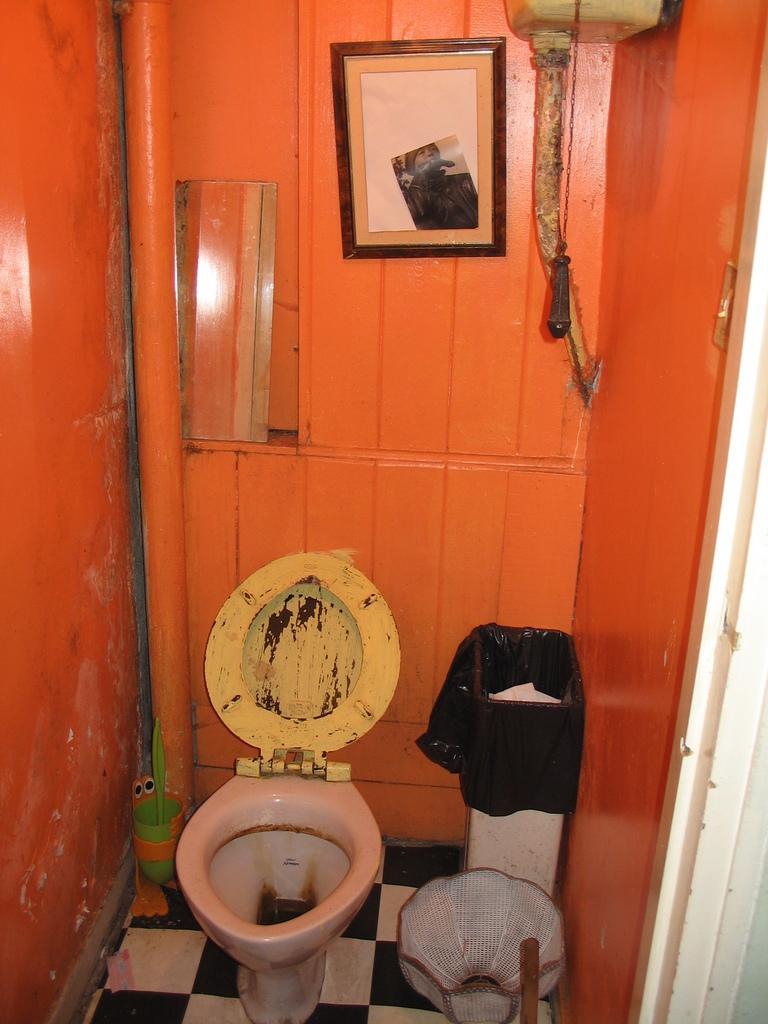Could you give a brief overview of what you see in this image? In this image there is a toilet seat, beside that there is a dustbin and there are a few objects on the floor. In the background there is a mirror, frame, geezer and a pipe are hanging on the wall. 